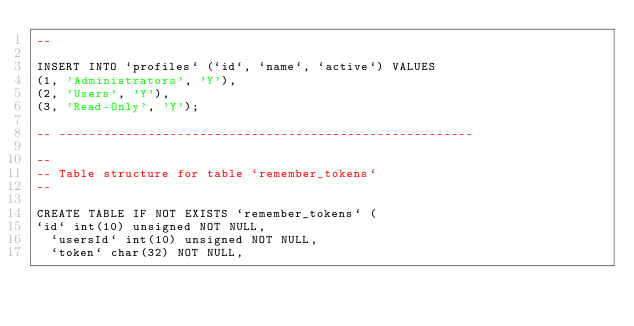<code> <loc_0><loc_0><loc_500><loc_500><_SQL_>--

INSERT INTO `profiles` (`id`, `name`, `active`) VALUES
(1, 'Administrators', 'Y'),
(2, 'Users', 'Y'),
(3, 'Read-Only', 'Y');

-- --------------------------------------------------------

--
-- Table structure for table `remember_tokens`
--

CREATE TABLE IF NOT EXISTS `remember_tokens` (
`id` int(10) unsigned NOT NULL,
  `usersId` int(10) unsigned NOT NULL,
  `token` char(32) NOT NULL,</code> 